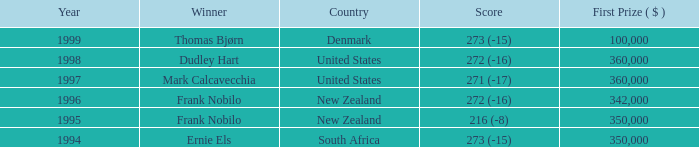What was the overall prize money in the years following 1996 with a score of 272 (-16) when frank nobilo emerged victorious? None. 